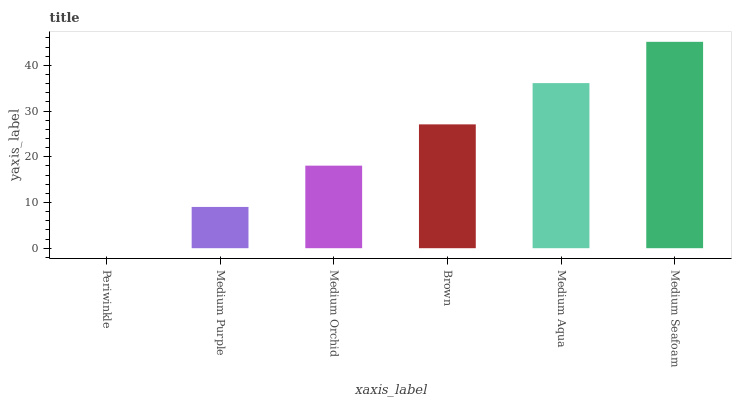Is Medium Purple the minimum?
Answer yes or no. No. Is Medium Purple the maximum?
Answer yes or no. No. Is Medium Purple greater than Periwinkle?
Answer yes or no. Yes. Is Periwinkle less than Medium Purple?
Answer yes or no. Yes. Is Periwinkle greater than Medium Purple?
Answer yes or no. No. Is Medium Purple less than Periwinkle?
Answer yes or no. No. Is Brown the high median?
Answer yes or no. Yes. Is Medium Orchid the low median?
Answer yes or no. Yes. Is Medium Aqua the high median?
Answer yes or no. No. Is Medium Aqua the low median?
Answer yes or no. No. 